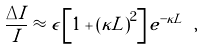Convert formula to latex. <formula><loc_0><loc_0><loc_500><loc_500>\frac { \Delta I } { I } \approx \epsilon \left [ 1 + \left ( \kappa L \right ) ^ { 2 } \right ] e ^ { - \kappa L } \ ,</formula> 